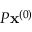Convert formula to latex. <formula><loc_0><loc_0><loc_500><loc_500>{ P } x ^ { ( 0 ) }</formula> 